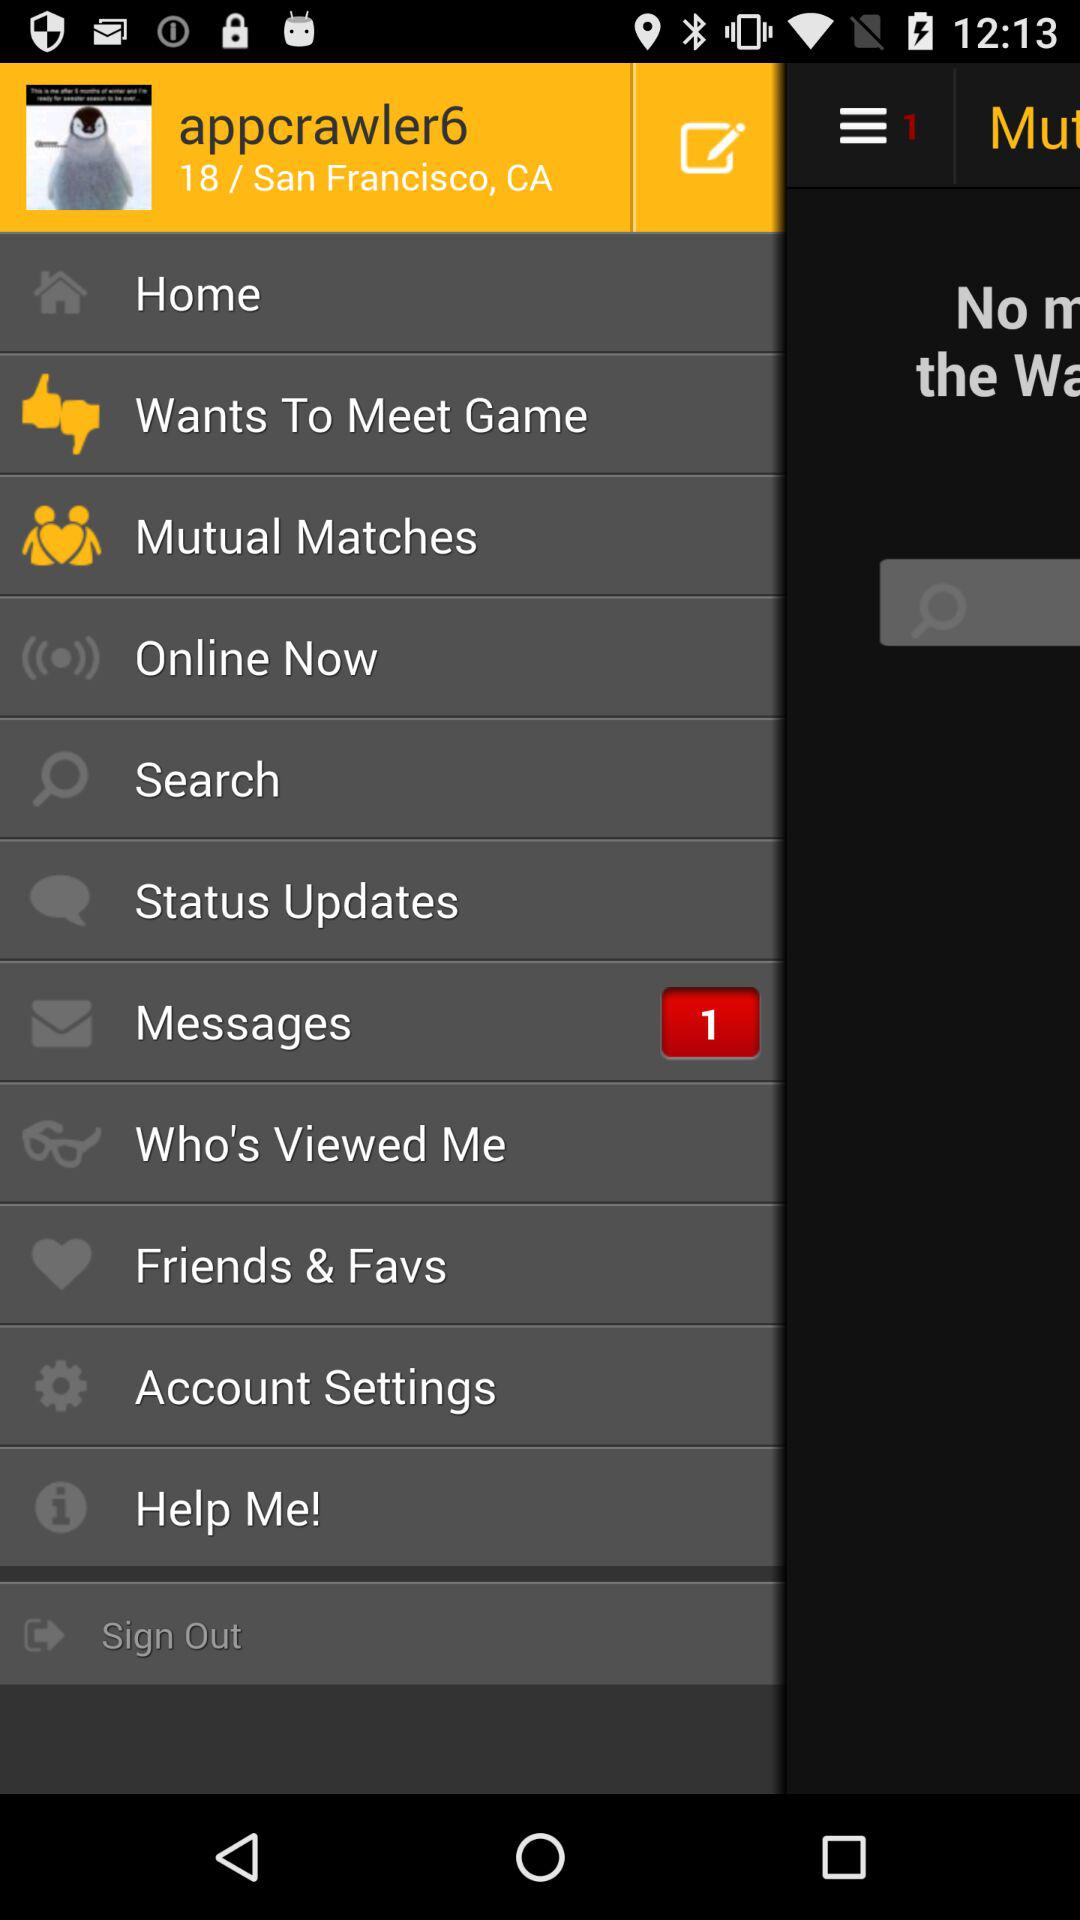What is the age? The age is 18 years old. 